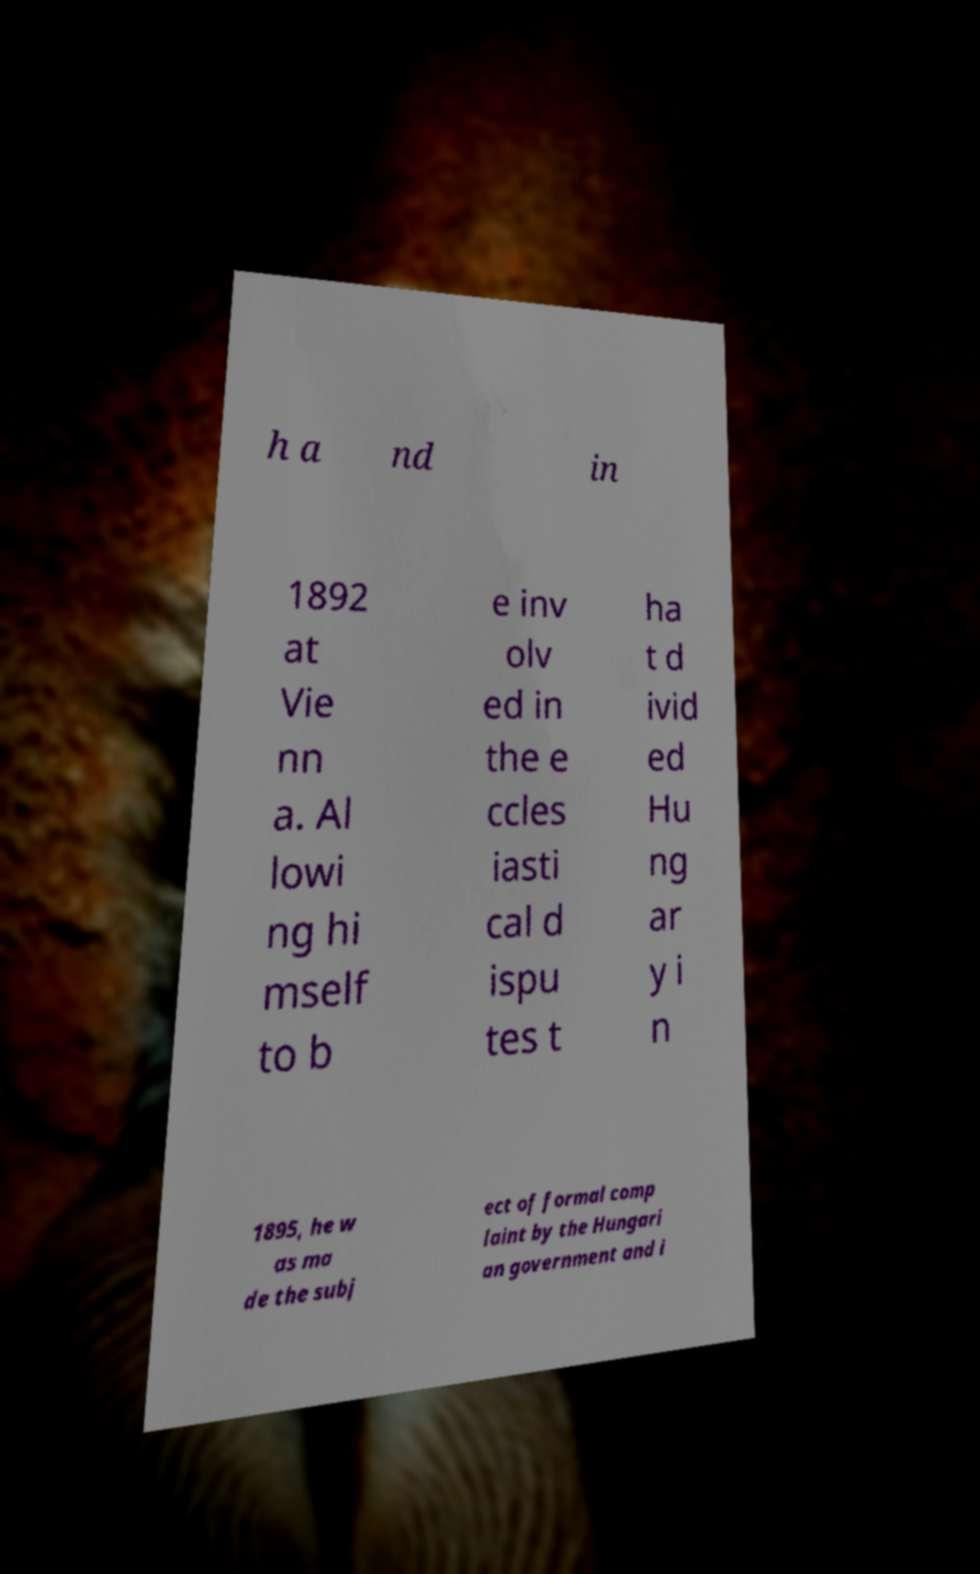What messages or text are displayed in this image? I need them in a readable, typed format. h a nd in 1892 at Vie nn a. Al lowi ng hi mself to b e inv olv ed in the e ccles iasti cal d ispu tes t ha t d ivid ed Hu ng ar y i n 1895, he w as ma de the subj ect of formal comp laint by the Hungari an government and i 